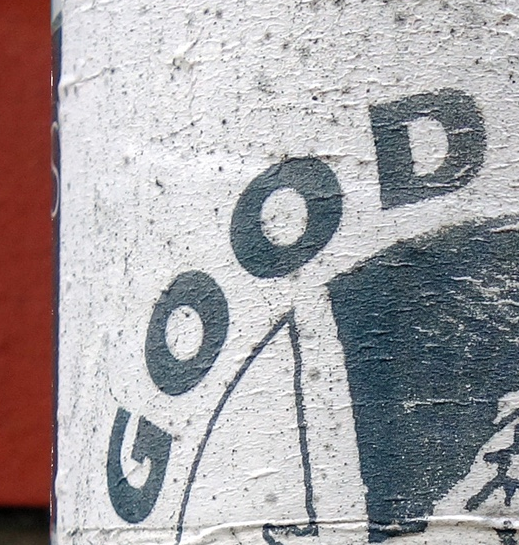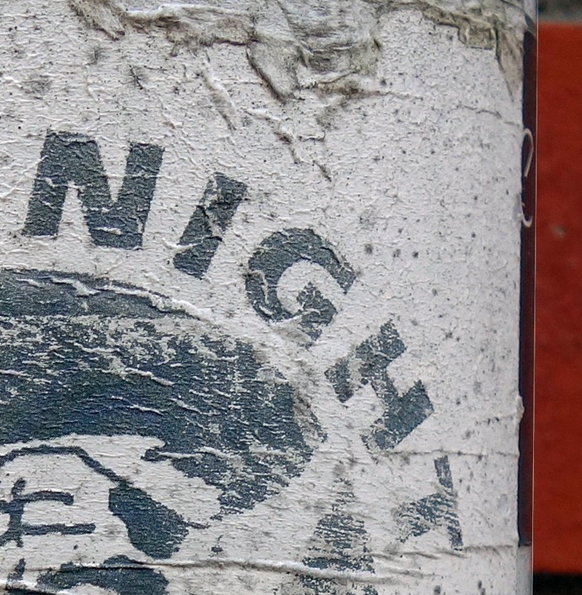What text is displayed in these images sequentially, separated by a semicolon? GOOD; NIGHT 